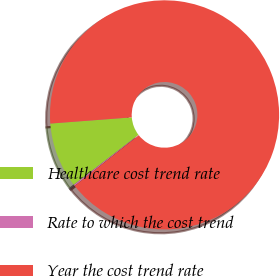Convert chart to OTSL. <chart><loc_0><loc_0><loc_500><loc_500><pie_chart><fcel>Healthcare cost trend rate<fcel>Rate to which the cost trend<fcel>Year the cost trend rate<nl><fcel>9.24%<fcel>0.2%<fcel>90.56%<nl></chart> 